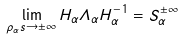<formula> <loc_0><loc_0><loc_500><loc_500>\lim _ { \rho _ { \alpha } s \to \pm \infty } H _ { \alpha } \varLambda _ { \alpha } H _ { \alpha } ^ { - 1 } = S _ { \alpha } ^ { \pm \infty }</formula> 